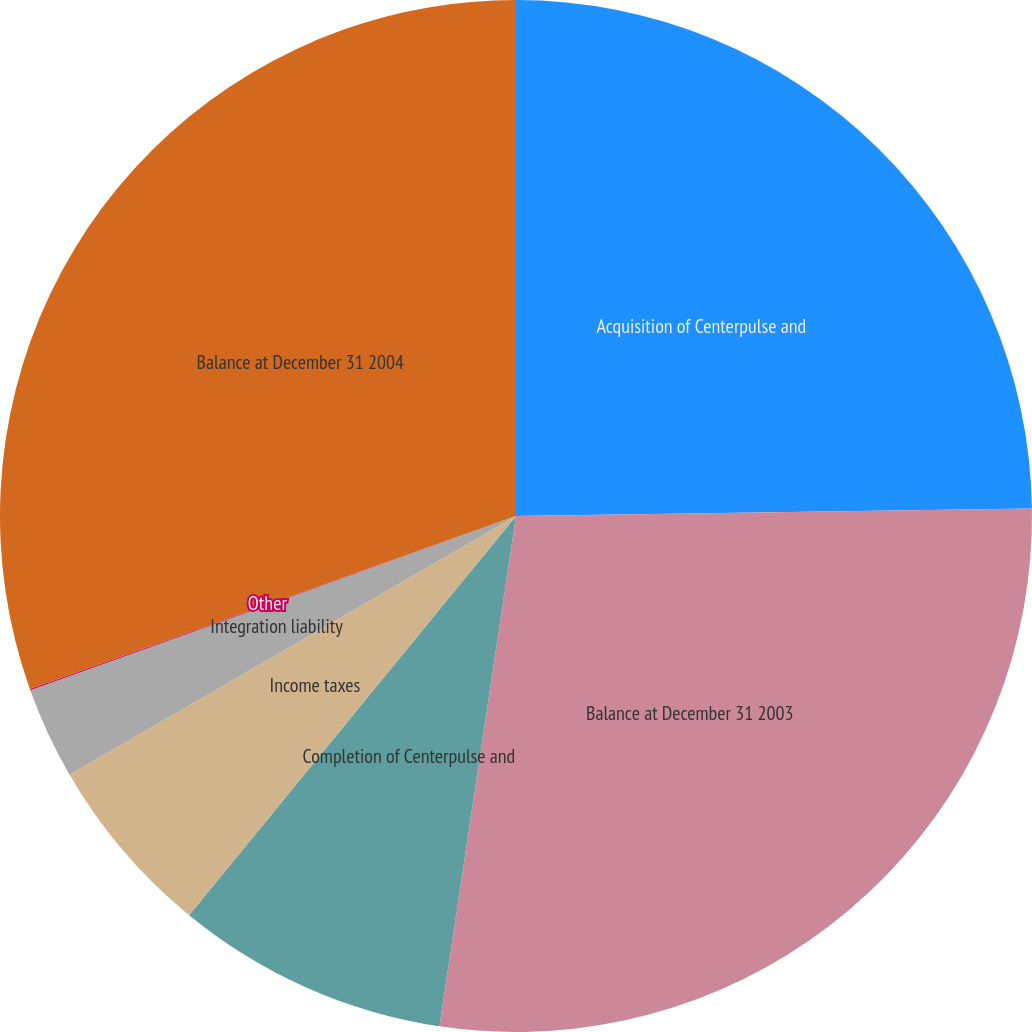<chart> <loc_0><loc_0><loc_500><loc_500><pie_chart><fcel>Acquisition of Centerpulse and<fcel>Balance at December 31 2003<fcel>Completion of Centerpulse and<fcel>Income taxes<fcel>Integration liability<fcel>Other<fcel>Balance at December 31 2004<nl><fcel>24.77%<fcel>27.6%<fcel>8.55%<fcel>5.72%<fcel>2.88%<fcel>0.04%<fcel>30.44%<nl></chart> 